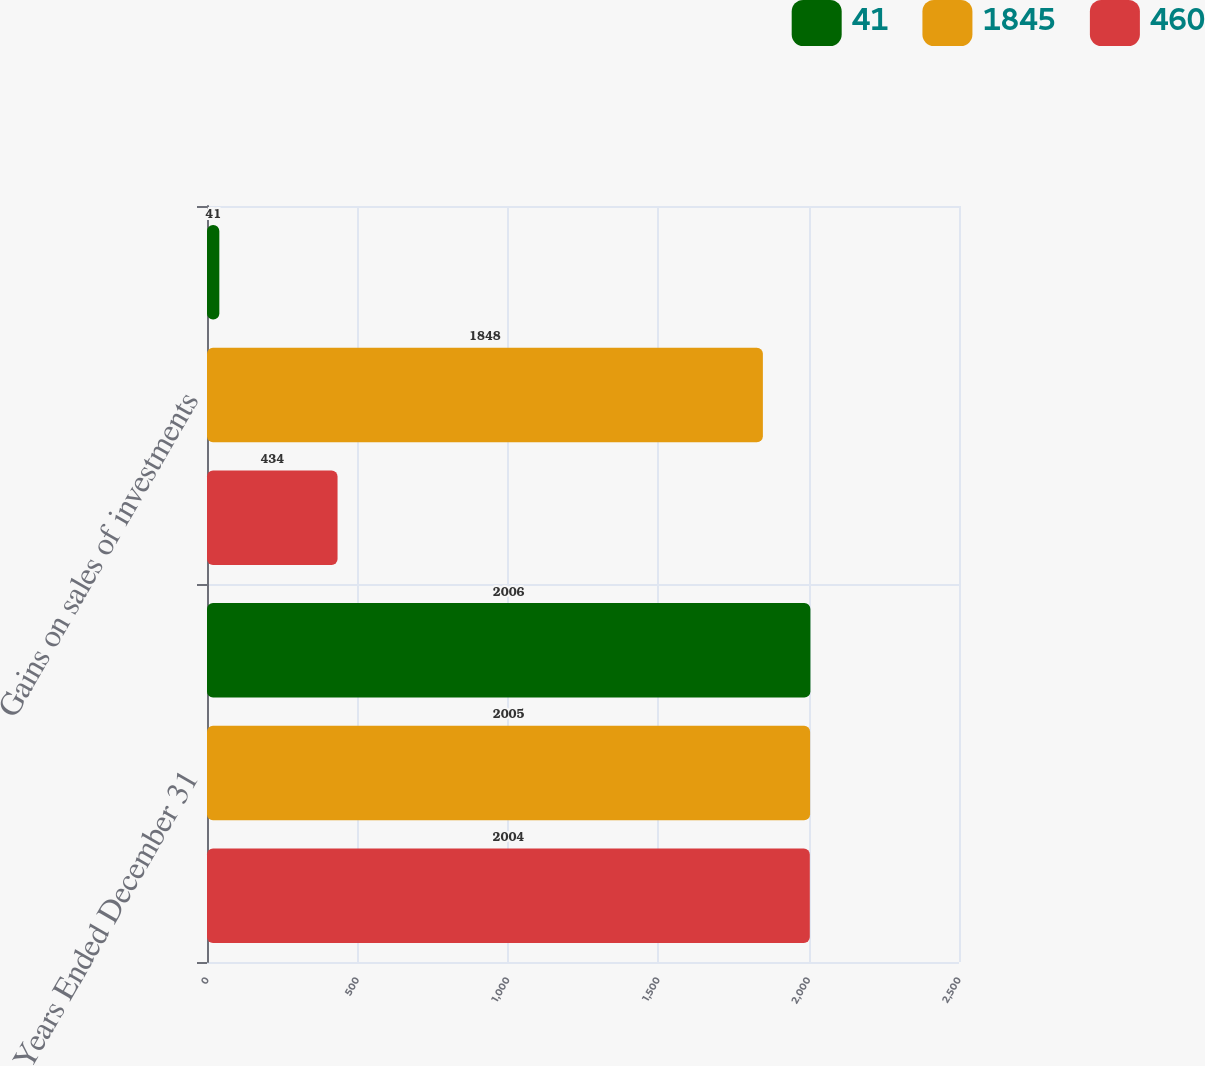<chart> <loc_0><loc_0><loc_500><loc_500><stacked_bar_chart><ecel><fcel>Years Ended December 31<fcel>Gains on sales of investments<nl><fcel>41<fcel>2006<fcel>41<nl><fcel>1845<fcel>2005<fcel>1848<nl><fcel>460<fcel>2004<fcel>434<nl></chart> 